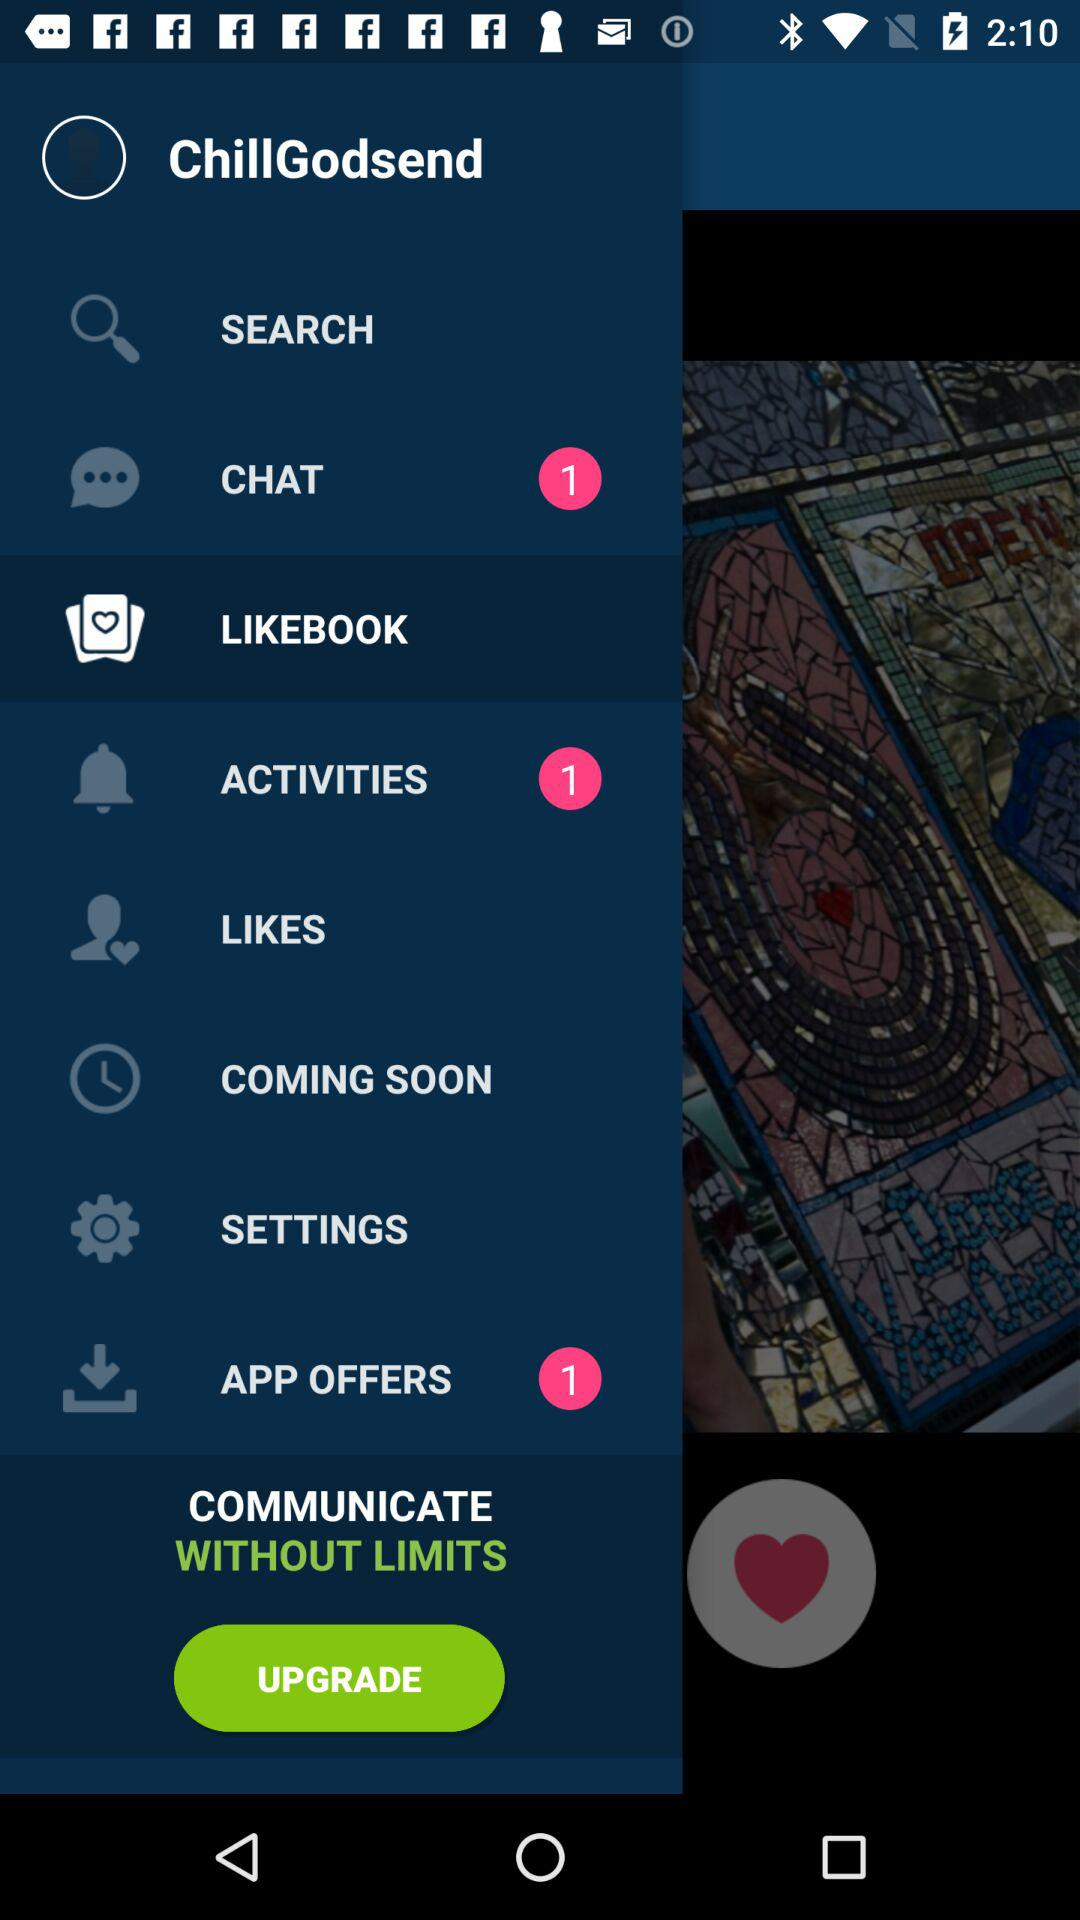How many app offers are there? There is 1 app offer. 